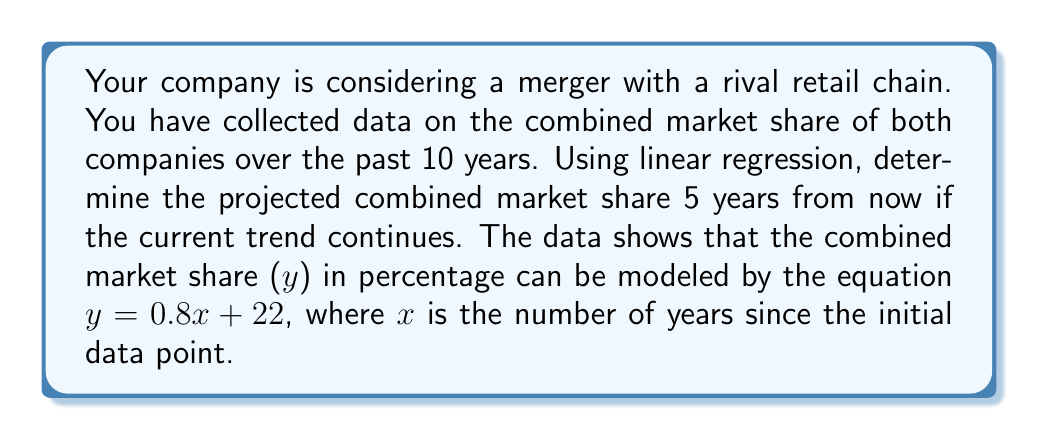Can you solve this math problem? To solve this problem, we'll follow these steps:

1) We are given the linear regression equation:
   $y = 0.8x + 22$

   Where:
   $y$ = combined market share (%)
   $x$ = number of years since initial data point

2) We need to find the projected market share 5 years from now. Since we already have 10 years of data, we need to calculate for $x = 15$.

3) Substitute $x = 15$ into the equation:

   $y = 0.8(15) + 22$

4) Simplify:
   $y = 12 + 22$
   $y = 34$

5) Therefore, the projected combined market share 5 years from now is 34%.

This analysis suggests that if the merger goes through and the current trend continues, the combined company could expect to hold about 34% of the market share in 5 years.
Answer: 34% 